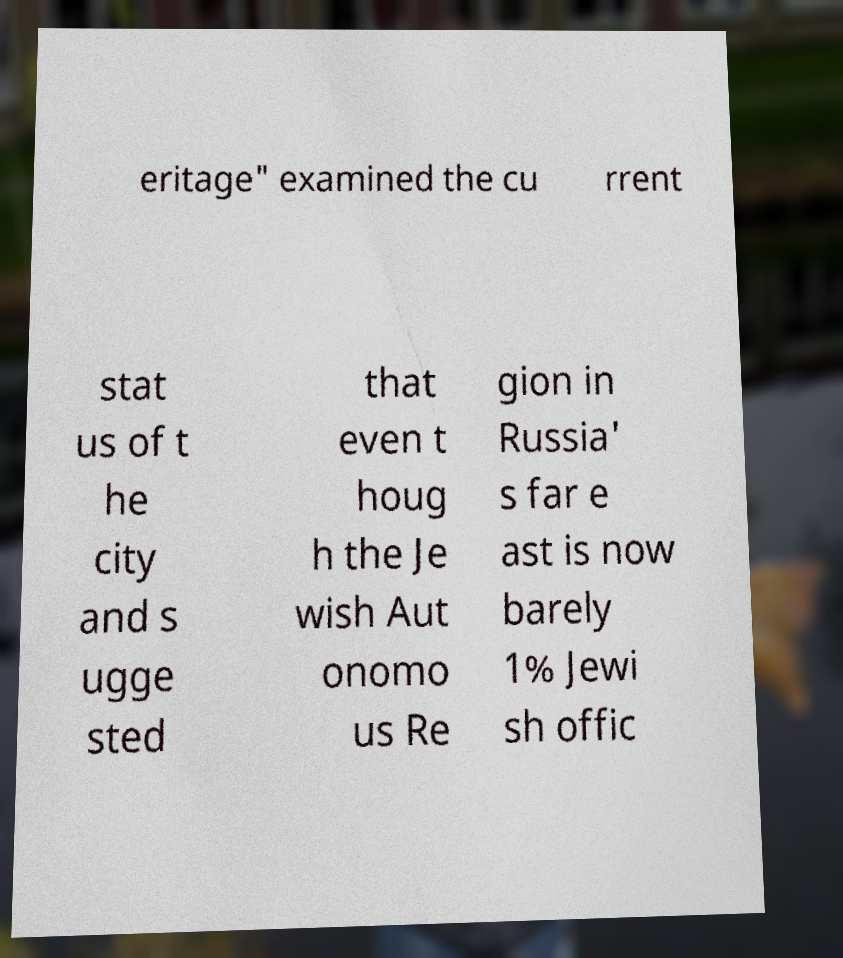For documentation purposes, I need the text within this image transcribed. Could you provide that? eritage" examined the cu rrent stat us of t he city and s ugge sted that even t houg h the Je wish Aut onomo us Re gion in Russia' s far e ast is now barely 1% Jewi sh offic 